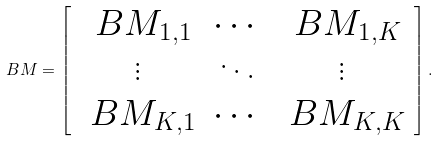<formula> <loc_0><loc_0><loc_500><loc_500>\ B { M } = \left [ \begin{array} { c c c } \ B { M } _ { 1 , 1 } & \cdots & \ B { M } _ { 1 , K } \\ \vdots & \ddots & \vdots \\ \ B { M } _ { K , 1 } & \cdots & \ B { M } _ { K , K } \end{array} \right ] .</formula> 